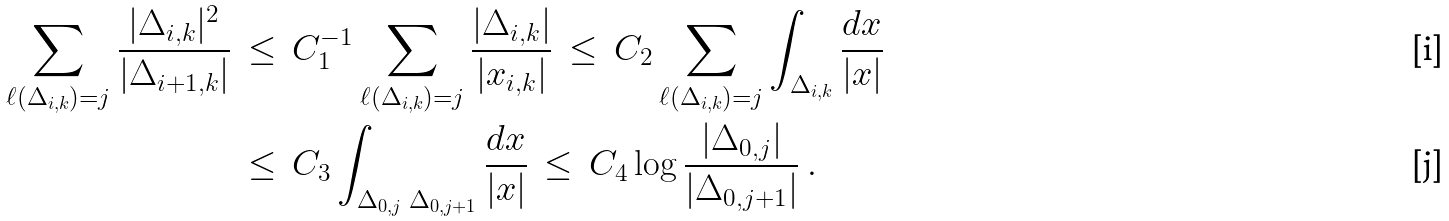Convert formula to latex. <formula><loc_0><loc_0><loc_500><loc_500>\sum _ { \ell ( \Delta _ { i , k } ) = j } \frac { | \Delta _ { i , k } | ^ { 2 } } { | \Delta _ { i + 1 , k } | } & \, \leq \, C _ { 1 } ^ { - 1 } \sum _ { \ell ( \Delta _ { i , k } ) = j } \frac { | \Delta _ { i , k } | } { | x _ { i , k } | } \, \leq \, C _ { 2 } \sum _ { \ell ( \Delta _ { i , k } ) = j } \int _ { \Delta _ { i , k } } \frac { d x } { | x | } \\ & \, \leq \, C _ { 3 } \int _ { \Delta _ { 0 , j } \ \Delta _ { 0 , j + 1 } } \frac { d x } { | x | } \, \leq \, C _ { 4 } \log \frac { | \Delta _ { 0 , j } | } { | \Delta _ { 0 , j + 1 } | } \ .</formula> 